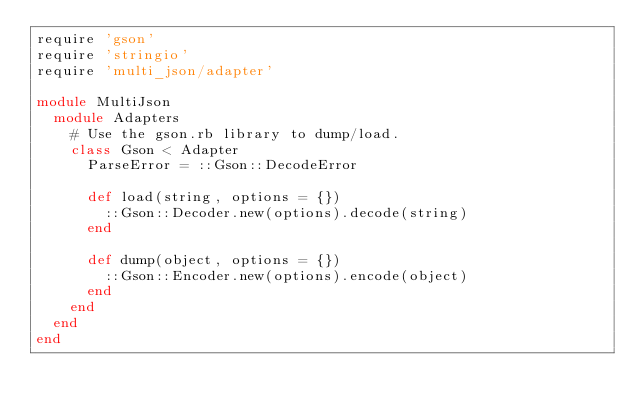<code> <loc_0><loc_0><loc_500><loc_500><_Ruby_>require 'gson'
require 'stringio'
require 'multi_json/adapter'

module MultiJson
  module Adapters
    # Use the gson.rb library to dump/load.
    class Gson < Adapter
      ParseError = ::Gson::DecodeError

      def load(string, options = {})
        ::Gson::Decoder.new(options).decode(string)
      end

      def dump(object, options = {})
        ::Gson::Encoder.new(options).encode(object)
      end
    end
  end
end
</code> 